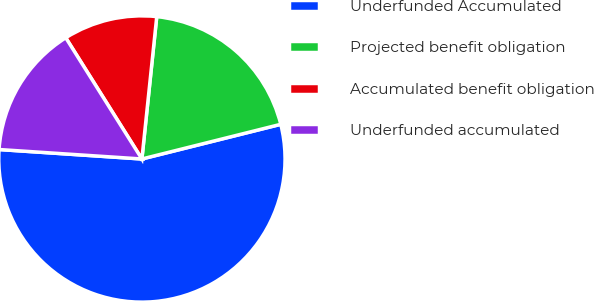Convert chart to OTSL. <chart><loc_0><loc_0><loc_500><loc_500><pie_chart><fcel>Underfunded Accumulated<fcel>Projected benefit obligation<fcel>Accumulated benefit obligation<fcel>Underfunded accumulated<nl><fcel>54.95%<fcel>19.45%<fcel>10.58%<fcel>15.02%<nl></chart> 